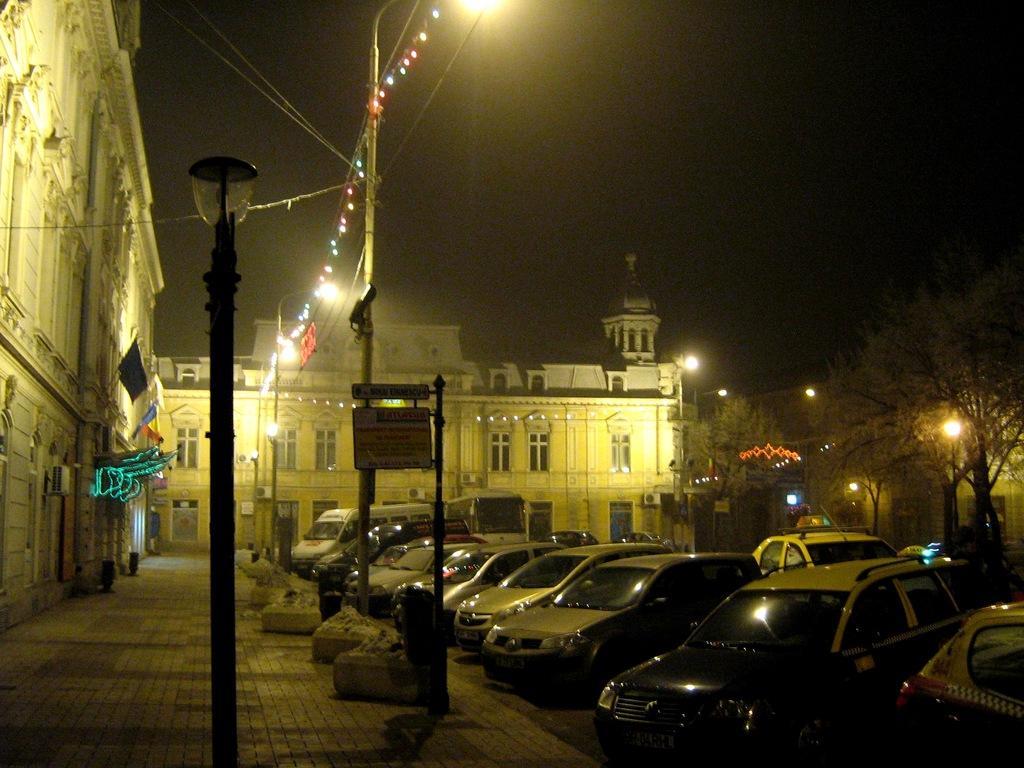Could you give a brief overview of what you see in this image? In this image we can see many cars on the ground, at the back there are trees, there are lights, there is a building, there are windows, in front there is a lamp, there is a sign board, there is a flag, there are wires, there is a sky. 